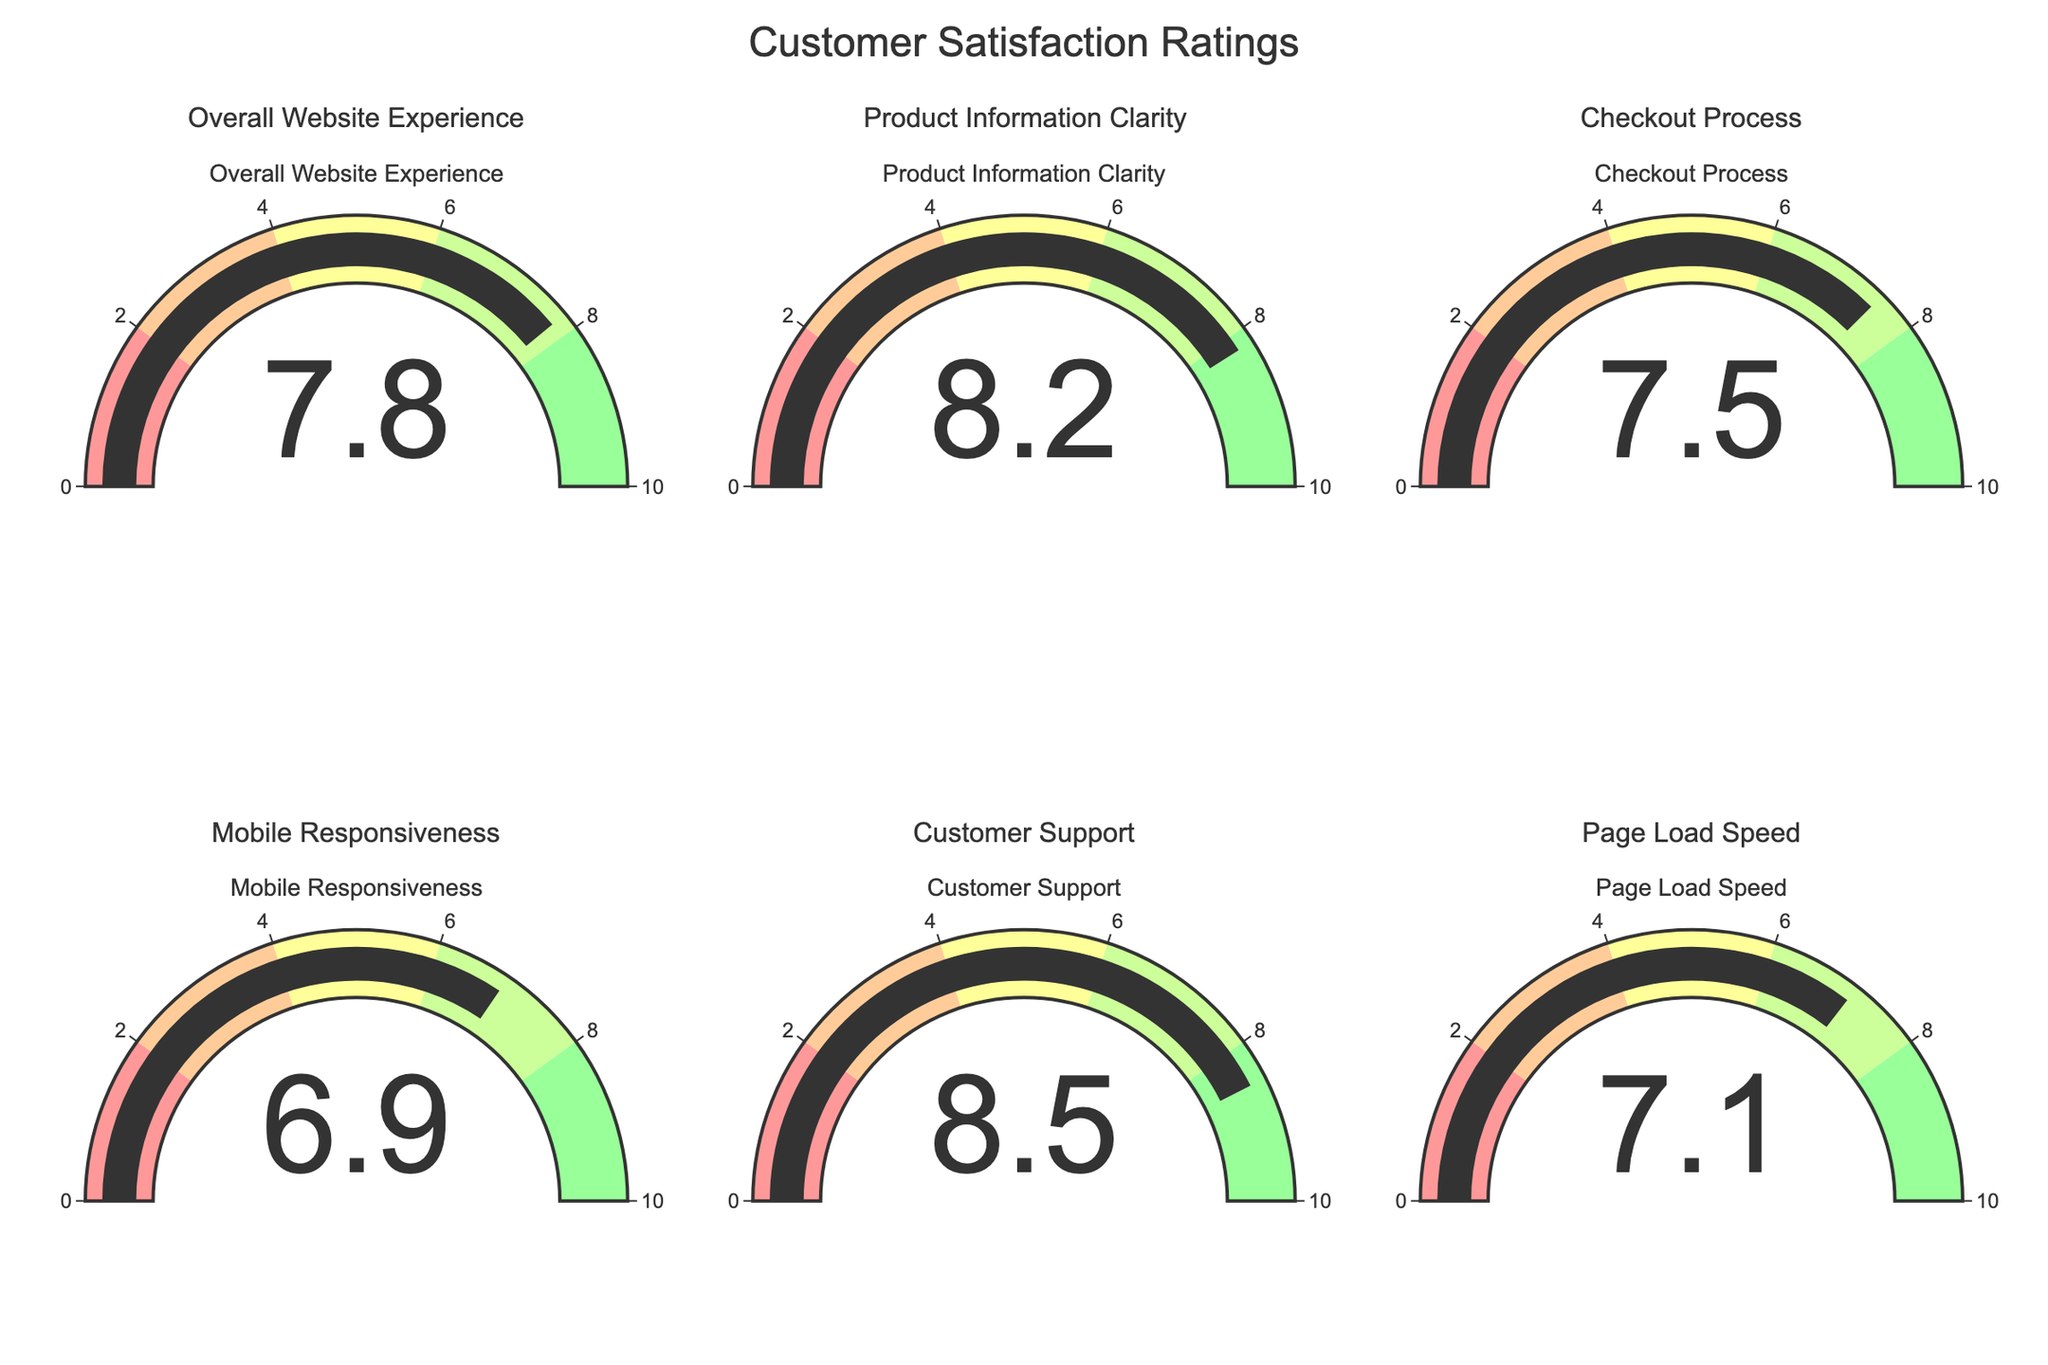What's the title of the figure? The title is typically found at the top of the figure and specifies what the figure represents. Here, it states "Customer Satisfaction Ratings."
Answer: Customer Satisfaction Ratings How many categories are depicted in the figure? The figure shows gauges for six different categories, each displayed in its own subplot, indicating six categories in total.
Answer: Six Which category has the highest customer satisfaction rating? By examining the values displayed on each gauge, the category "Customer Support" has the highest rating at 8.5.
Answer: Customer Support What is the average rating across all categories? To find the average, sum all the ratings (7.8 + 8.2 + 7.5 + 6.9 + 8.5 + 7.1 = 46) and divide by the number of categories (6). The average is 46 / 6 = 7.67.
Answer: 7.67 What is the color range that "Mobile Responsiveness" falls into? The gauge for "Mobile Responsiveness" shows a rating of 6.9, which falls into the greenish color representing ratings between 6 and 8.
Answer: Greenish Which category has a rating closest to 8? "Product Information Clarity" has a rating of 8.2, which is the closest to 8 among all categories listed.
Answer: Product Information Clarity How much higher is the rating of "Customer Support" compared to "Checkout Process"? "Customer Support" rating is 8.5, and "Checkout Process" is 7.5. The difference is found by subtracting 7.5 from 8.5, which equals 1.0.
Answer: 1.0 Which category has the lowest rating? Looking at all the gauge values, "Mobile Responsiveness" has the lowest rating at 6.9.
Answer: Mobile Responsiveness Are there more categories with ratings above or below 7.5? To determine this, count the number of categories above 7.5: "Overall Website Experience," "Product Information Clarity," and "Customer Support" (3 categories). Categories below 7.5: "Checkout Process," "Mobile Responsiveness," and "Page Load Speed" (3 categories).
Answer: Equal 